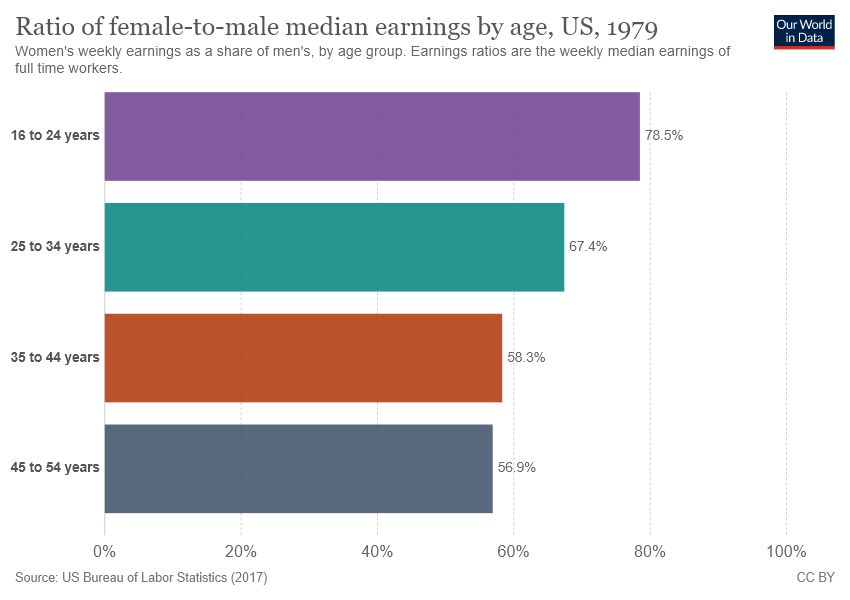Give some essential details in this illustration. The difference between the smallest two bars is not equal to 1/4 times the value of the smallest bar. There are 4 colors in the graph. 